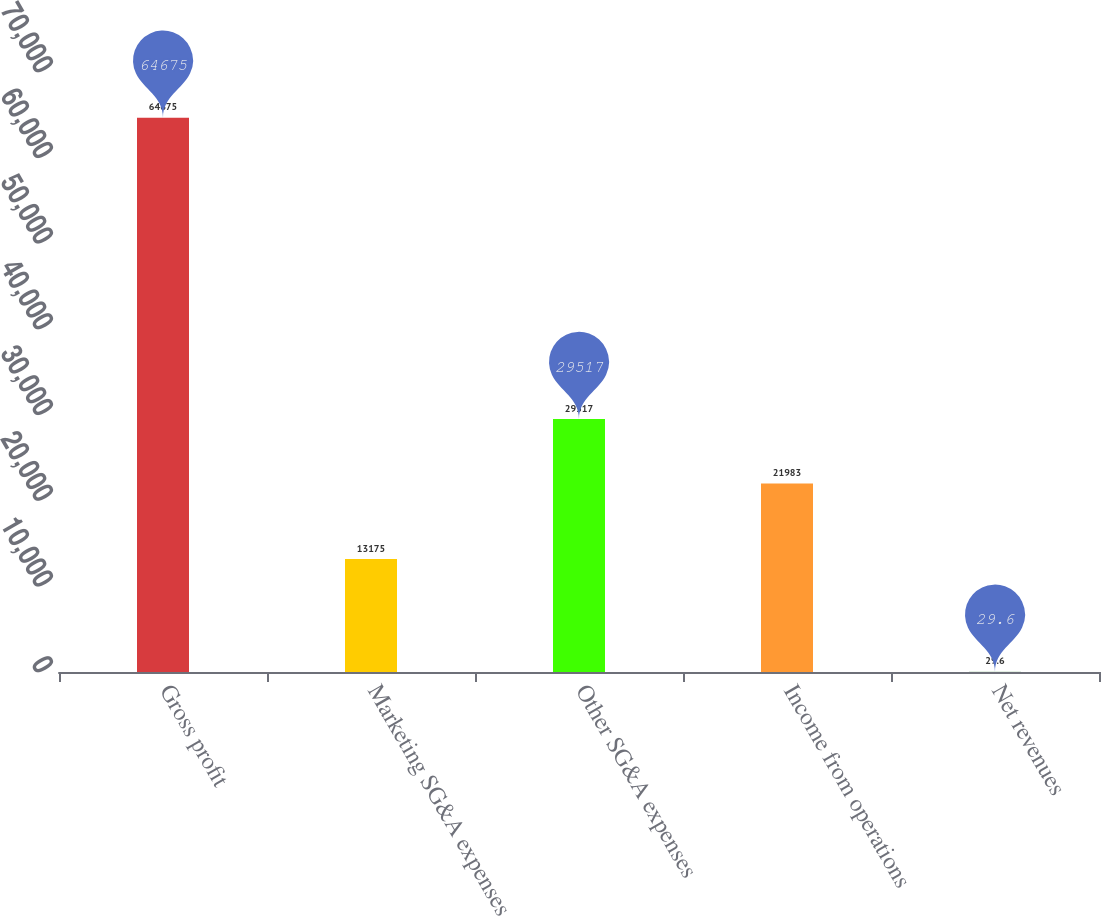Convert chart to OTSL. <chart><loc_0><loc_0><loc_500><loc_500><bar_chart><fcel>Gross profit<fcel>Marketing SG&A expenses<fcel>Other SG&A expenses<fcel>Income from operations<fcel>Net revenues<nl><fcel>64675<fcel>13175<fcel>29517<fcel>21983<fcel>29.6<nl></chart> 